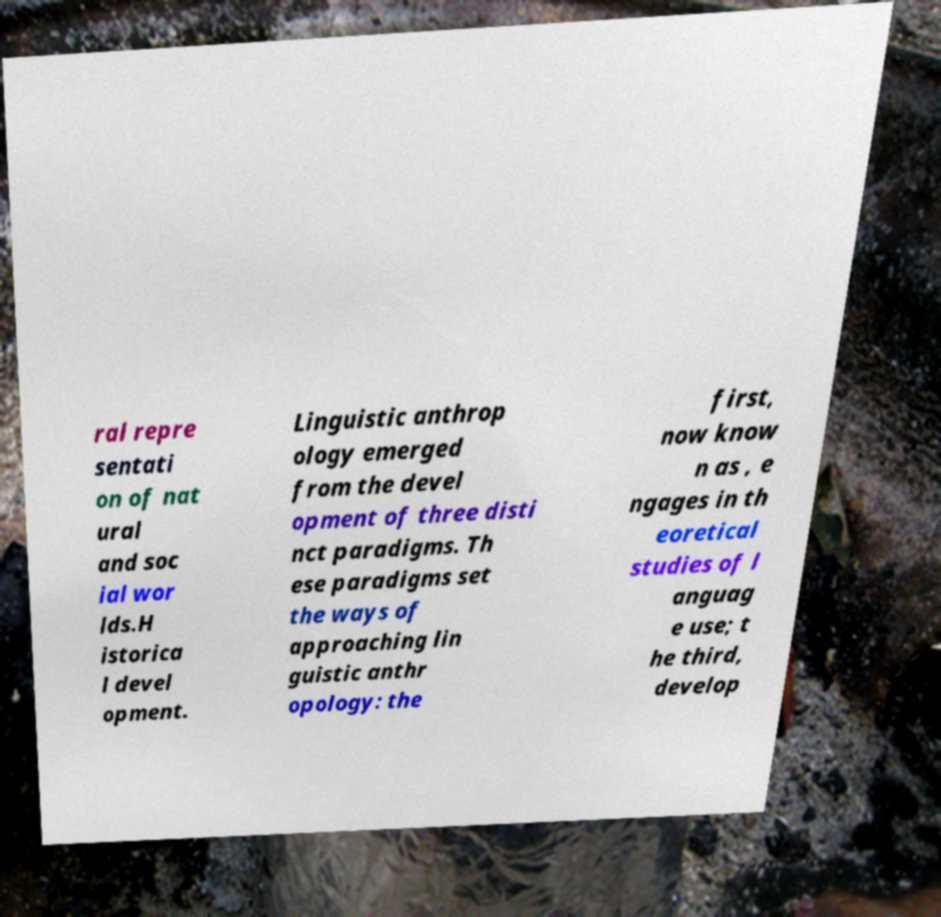Could you extract and type out the text from this image? ral repre sentati on of nat ural and soc ial wor lds.H istorica l devel opment. Linguistic anthrop ology emerged from the devel opment of three disti nct paradigms. Th ese paradigms set the ways of approaching lin guistic anthr opology: the first, now know n as , e ngages in th eoretical studies of l anguag e use; t he third, develop 